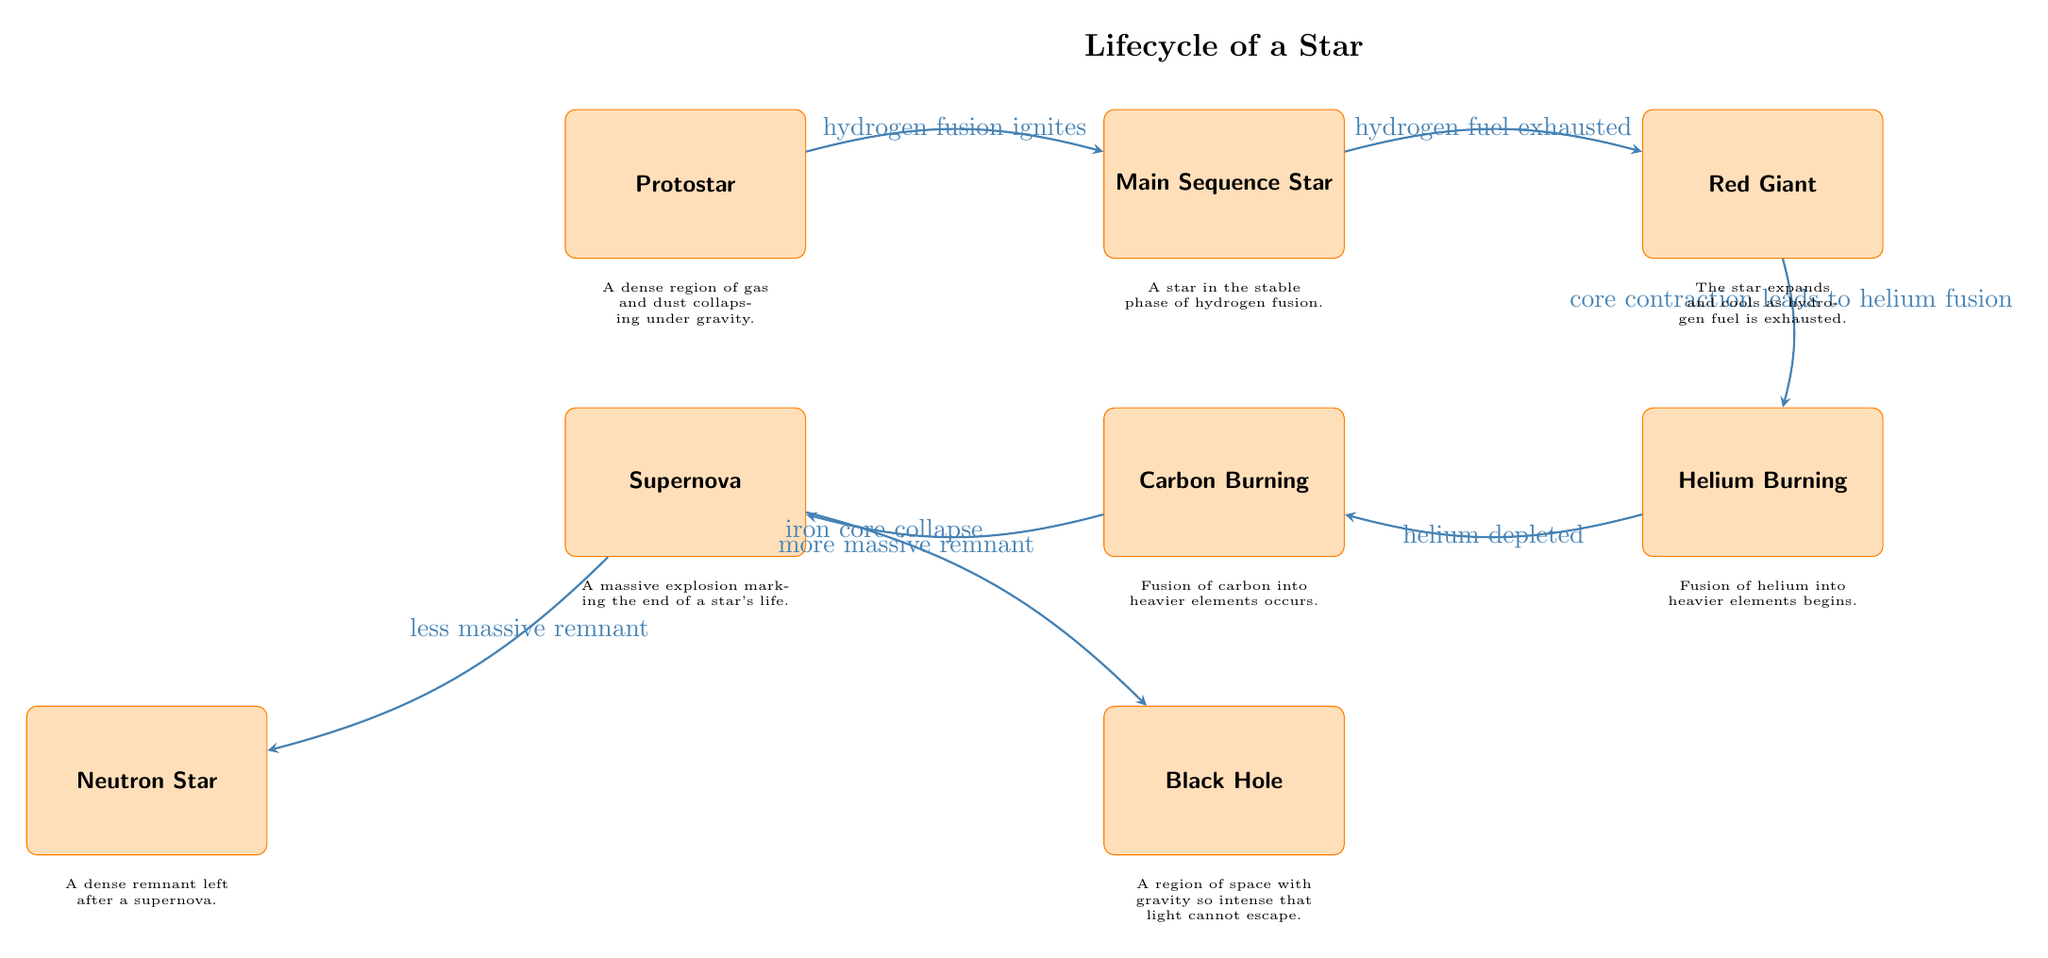What is the first stage of the star lifecycle? The diagram shows the first node labeled "Protostar," indicating it is the initial stage of a star's lifecycle.
Answer: Protostar What follows the main sequence star? The diagram illustrates an arrow pointing from "Main Sequence Star" to "Red Giant," indicating that this is the next stage after the main sequence.
Answer: Red Giant How many intermediary phases are between protostar and supernova? By counting the nodes from "Protostar" to "Supernova," there are three intermediary phases: "Main Sequence Star," "Red Giant," and "Helium Burning," totaling four stages.
Answer: 4 What marks the end of a star's life? The label of the "Supernova" node describes it as a "massive explosion marking the end of a star's life," thus indicating its significance.
Answer: Supernova What occurs when hydrogen fuel is exhausted? The arrow leading from "Main Sequence Star" to "Red Giant" is labeled with "hydrogen fuel exhausted," indicating this transition occurs at this point.
Answer: Red Giant What is formed from a less massive remnant after a supernova? The diagram points from "Supernova" to "Neutron Star," indicating that a less massive remnant results in a neutron star after the supernova explosion.
Answer: Neutron Star Which process initiates the transition from protostar to main sequence star? The arrow from "Protostar" to "Main Sequence Star" is labeled "hydrogen fusion ignites," showing that this process starts the transition.
Answer: Hydrogen fusion ignites What two outcomes can occur after a supernova? The diagram displays two arrows leading from "Supernova" to both "Neutron Star" and "Black Hole," specifying that these are the two possible outcomes post-supernova.
Answer: Neutron Star, Black Hole What's the role of core contraction in the lifecycle of a star? The arrow from "Red Giant" to "Helium Burning" indicates that "core contraction leads to helium fusion," highlighting the importance of this process in the transformation.
Answer: Helium fusion 